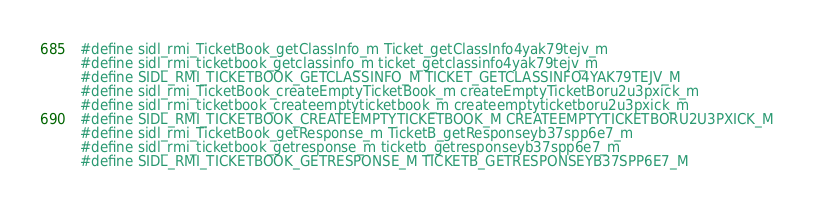Convert code to text. <code><loc_0><loc_0><loc_500><loc_500><_C_>#define sidl_rmi_TicketBook_getClassInfo_m Ticket_getClassInfo4yak79tejv_m
#define sidl_rmi_ticketbook_getclassinfo_m ticket_getclassinfo4yak79tejv_m
#define SIDL_RMI_TICKETBOOK_GETCLASSINFO_M TICKET_GETCLASSINFO4YAK79TEJV_M
#define sidl_rmi_TicketBook_createEmptyTicketBook_m createEmptyTicketBoru2u3pxick_m
#define sidl_rmi_ticketbook_createemptyticketbook_m createemptyticketboru2u3pxick_m
#define SIDL_RMI_TICKETBOOK_CREATEEMPTYTICKETBOOK_M CREATEEMPTYTICKETBORU2U3PXICK_M
#define sidl_rmi_TicketBook_getResponse_m TicketB_getResponseyb37spp6e7_m
#define sidl_rmi_ticketbook_getresponse_m ticketb_getresponseyb37spp6e7_m
#define SIDL_RMI_TICKETBOOK_GETRESPONSE_M TICKETB_GETRESPONSEYB37SPP6E7_M</code> 